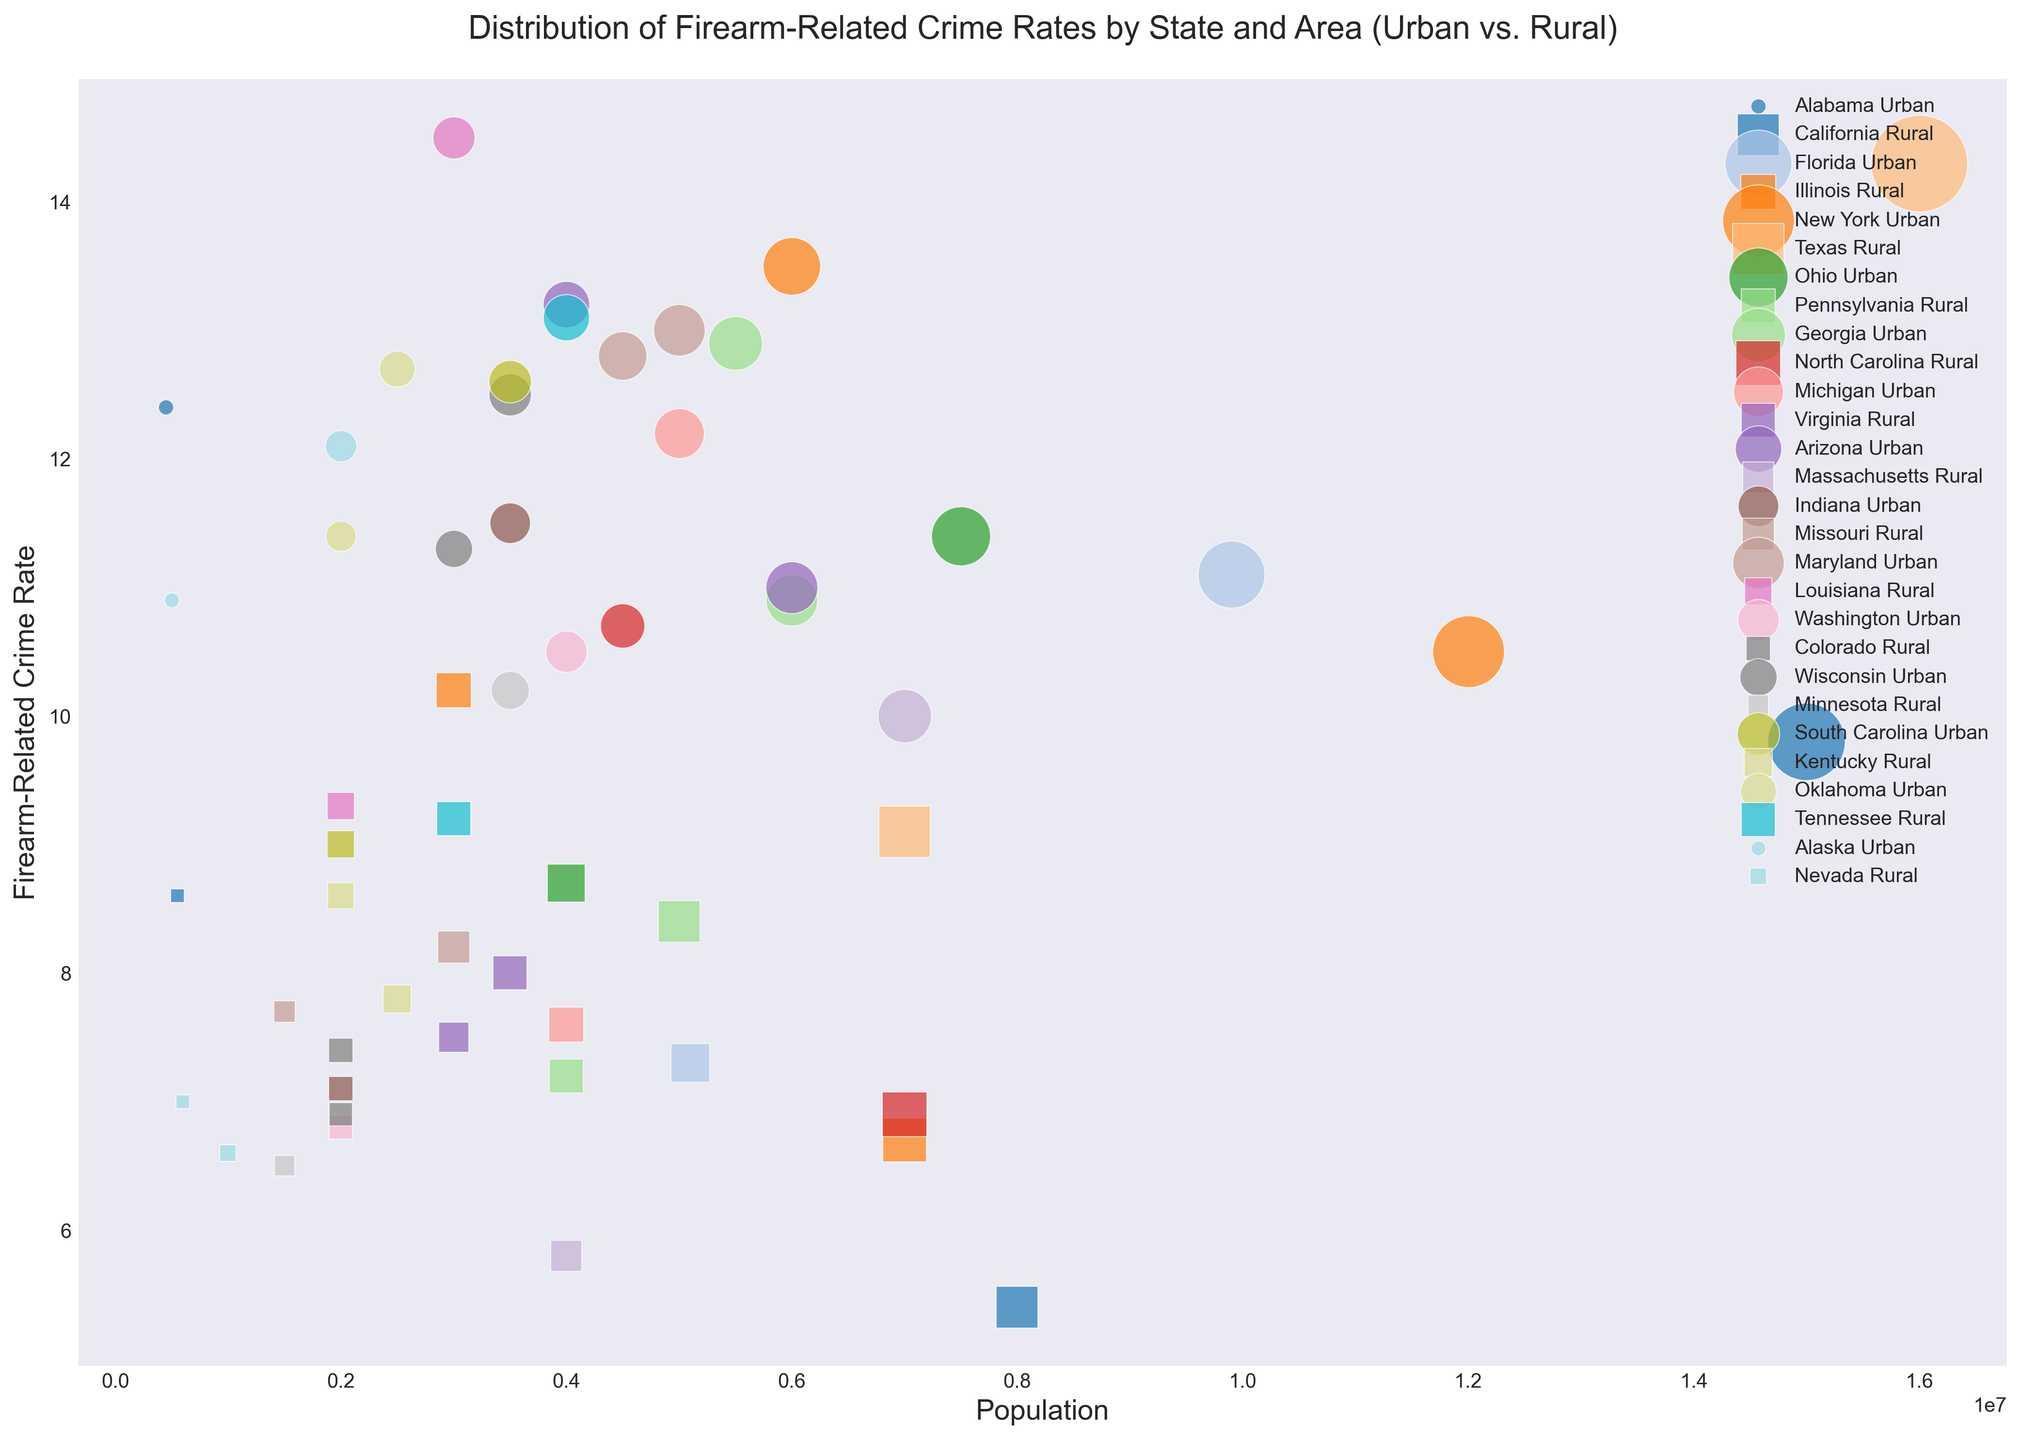what state has the highest firearm-related crime rate in urban areas? Looking at the scatter plot, identify the point representing the highest y-value (crime rate) in the set of circles (urban areas). Texas has a y-value of 14.3 which is the highest.
Answer: Texas What is the difference in firearm-related crime rates between urban and rural areas of Illinois? Identify the y-values for both the urban and rural areas of Illinois. Urban Illinois has a crime rate of 13.5, and rural Illinois has a crime rate of 10.2. Subtract the rural value from the urban value: 13.5 - 10.2 = 3.3.
Answer: 3.3 Which state has the largest population in a rural area shown in the figure? Look at the x-axis values of the squares (representing rural areas) and find the one with the largest x-value. Rural California has a population of 8,000,000 which is the largest in the rural category.
Answer: California In which state does the urban area have a greater population than the rural area by the widest margin? Compare the x-values (population) for urban and rural areas for each state and find the largest difference. California has 15,000,000 in urban and 8,000,000 in rural areas, so the difference is 15,000,000 - 8,000,000 = 7,000,000, which is the widest margin.
Answer: California Which state has the smallest difference in firearm-related crime rates between urban and rural areas? Calculate the difference in y-values (crime rates) for urban and rural areas for each state and find the smallest value. Alaska has crime rates of 10.9 (urban) and 7.0 (rural), with a difference of 10.9 - 7.0 = 3.9, which is the smallest difference.
Answer: Alaska What is the relationship between population size and firearm-related crime rate in urban areas? Observe the general trend of how the y-values (crime rates) change as the x-values (population) increase for the circles (urban areas). It appears that while there are slight variations, there is no strong direct correlation observed between urban population size and firearm-related crime rate.
Answer: No strong correlation Which urban area has the lowest firearm-related crime rate and what is the population size of that area? Identify the circle with the lowest y-value (crime rate) among the urban areas. California has the lowest urban crime rate at 9.8, and its population is 15,000,000.
Answer: California, 15,000,000 Are there more states with higher firearm-related crime rates in urban areas than in rural areas? Count the number of instances where the y-value (crime rate) for urban areas exceeds that for rural areas within the same state. In this dataset, all the states show higher firearm-related crime rates in urban areas than in rural areas.
Answer: Yes For New York, what is the sum of firearm-related crime rates for urban and rural areas? Add the y-values (crime rates) for both the urban and rural areas of New York. Urban New York has a crime rate of 10.5, and rural New York has a crime rate of 6.7. The sum is 10.5 + 6.7 = 17.2.
Answer: 17.2 